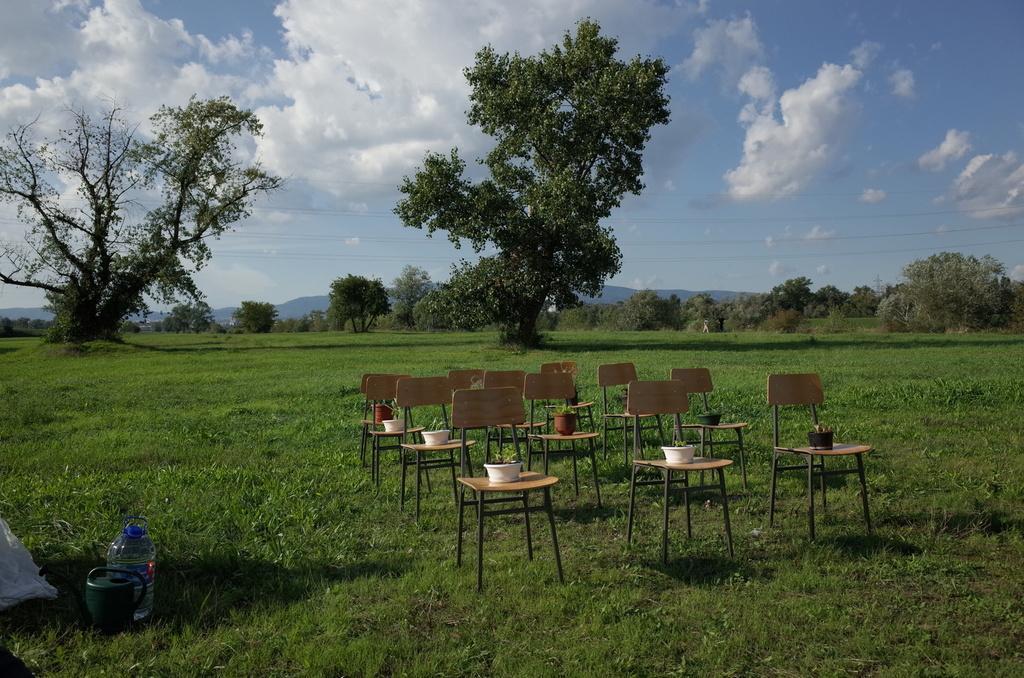Please provide a concise description of this image. These are the chairs with the flower pots on it. Here is the grass. I can see the trees with branches and leaves. These are the clouds in the sky. I can see a can and a kettle placed on the grass. 